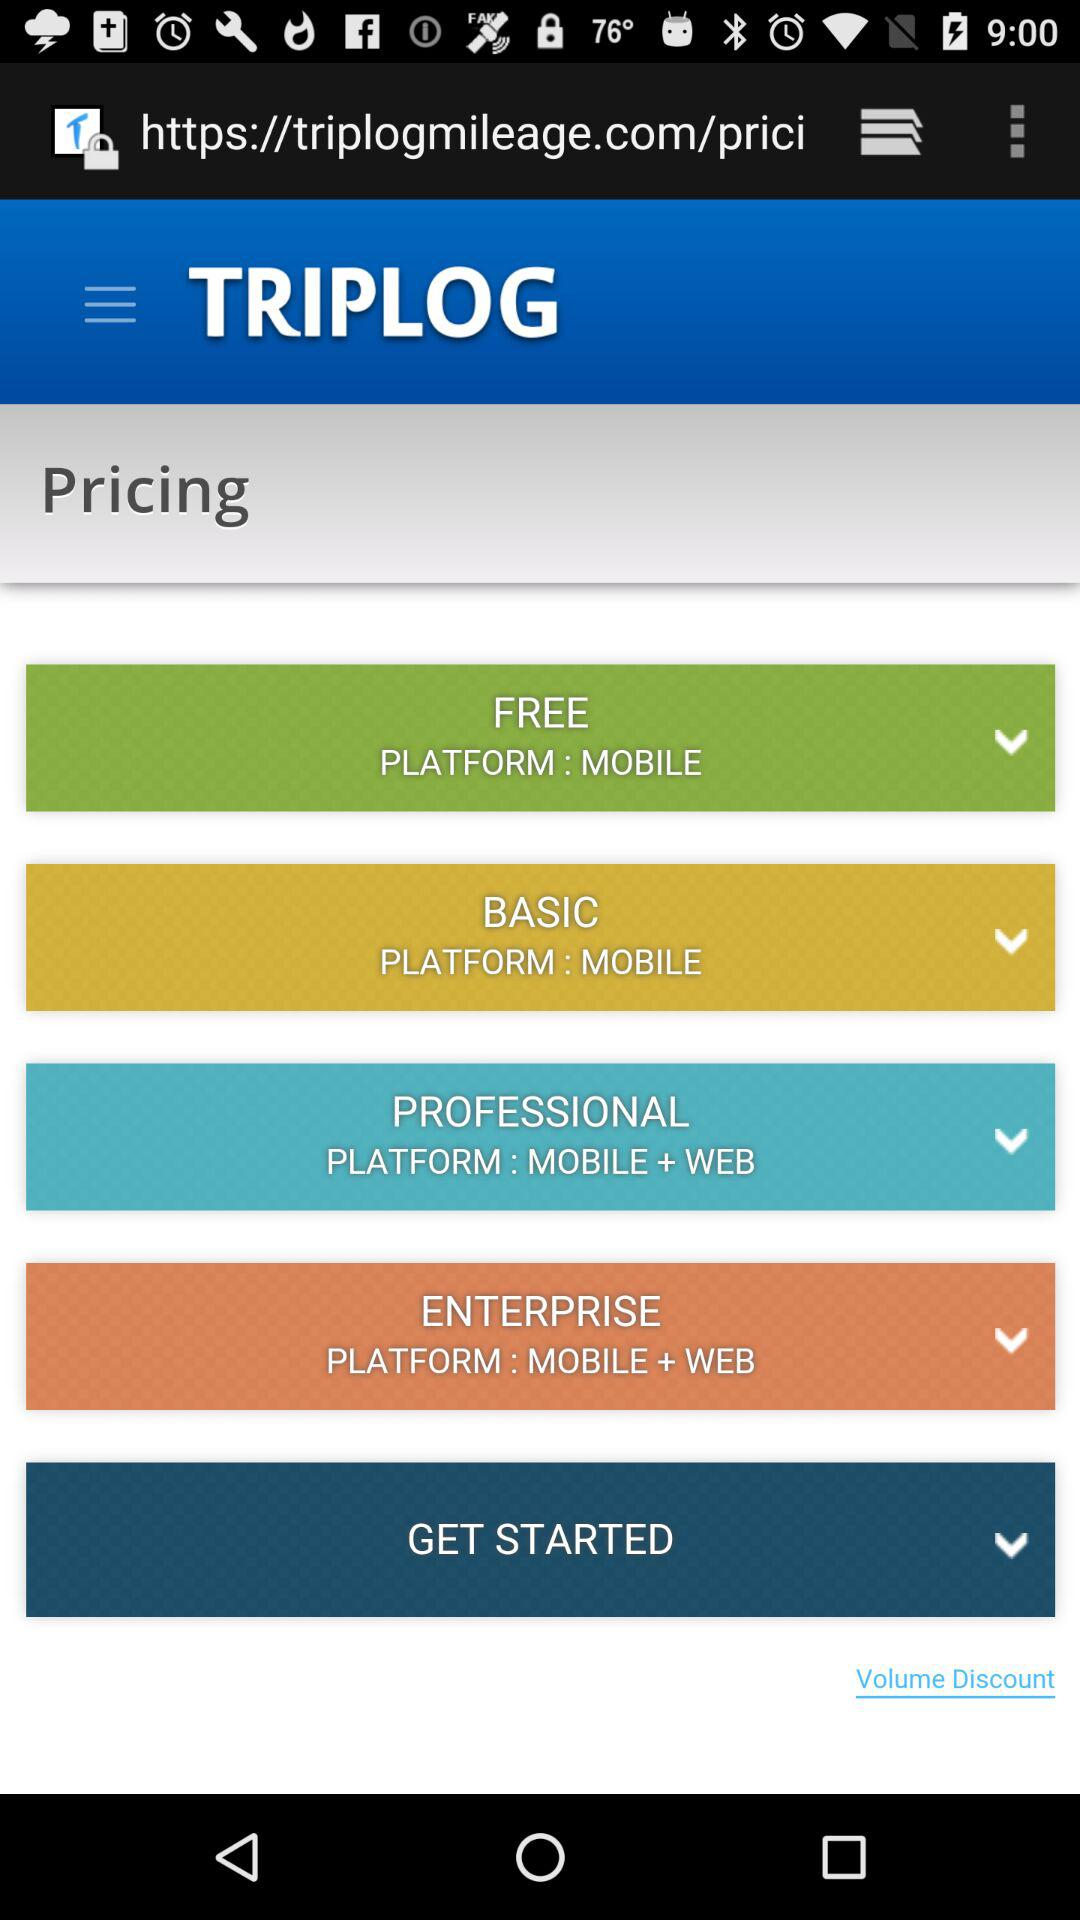How many pricing options are available?
Answer the question using a single word or phrase. 4 